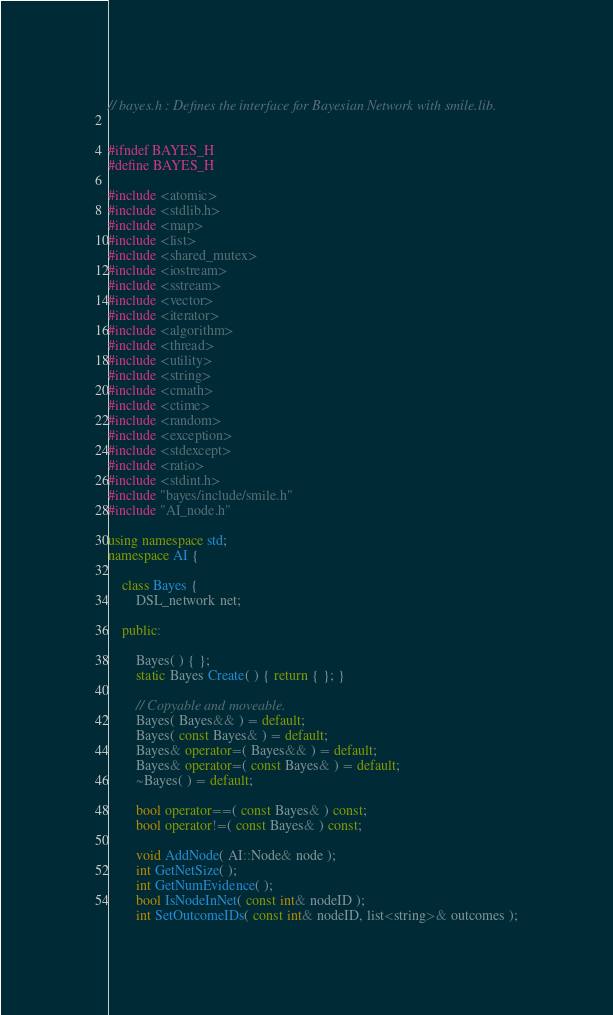Convert code to text. <code><loc_0><loc_0><loc_500><loc_500><_C++_>// bayes.h : Defines the interface for Bayesian Network with smile.lib.  


#ifndef BAYES_H
#define BAYES_H

#include <atomic>
#include <stdlib.h>
#include <map>
#include <list>
#include <shared_mutex>
#include <iostream>
#include <sstream>
#include <vector>
#include <iterator>
#include <algorithm>
#include <thread>
#include <utility> 
#include <string>
#include <cmath>
#include <ctime>
#include <random>
#include <exception>
#include <stdexcept>
#include <ratio>
#include <stdint.h>
#include "bayes/include/smile.h"
#include "AI_node.h"

using namespace std;
namespace AI {

	class Bayes {
		DSL_network net;

	public:

		Bayes( ) { };
		static Bayes Create( ) { return { }; }

		// Copyable and moveable.
		Bayes( Bayes&& ) = default;
		Bayes( const Bayes& ) = default;
		Bayes& operator=( Bayes&& ) = default;
		Bayes& operator=( const Bayes& ) = default;
		~Bayes( ) = default;

		bool operator==( const Bayes& ) const;
		bool operator!=( const Bayes& ) const;

		void AddNode( AI::Node& node );
		int GetNetSize( );
		int GetNumEvidence( );
		bool IsNodeInNet( const int& nodeID );
		int SetOutcomeIDs( const int& nodeID, list<string>& outcomes );</code> 